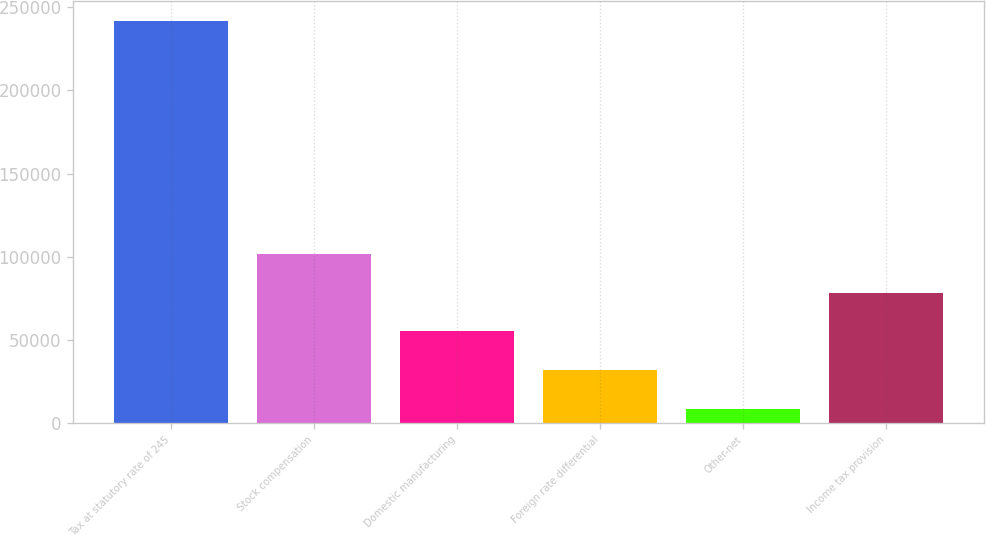Convert chart. <chart><loc_0><loc_0><loc_500><loc_500><bar_chart><fcel>Tax at statutory rate of 245<fcel>Stock compensation<fcel>Domestic manufacturing<fcel>Foreign rate differential<fcel>Other-net<fcel>Income tax provision<nl><fcel>241853<fcel>101664<fcel>54934.6<fcel>31569.8<fcel>8205<fcel>78299.4<nl></chart> 